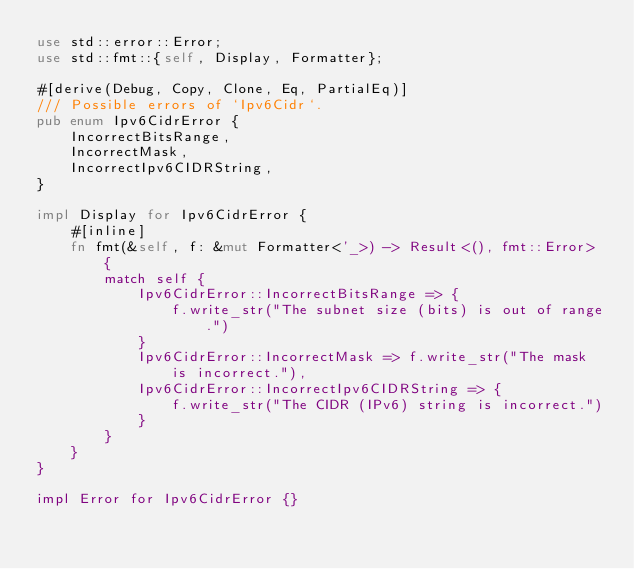<code> <loc_0><loc_0><loc_500><loc_500><_Rust_>use std::error::Error;
use std::fmt::{self, Display, Formatter};

#[derive(Debug, Copy, Clone, Eq, PartialEq)]
/// Possible errors of `Ipv6Cidr`.
pub enum Ipv6CidrError {
    IncorrectBitsRange,
    IncorrectMask,
    IncorrectIpv6CIDRString,
}

impl Display for Ipv6CidrError {
    #[inline]
    fn fmt(&self, f: &mut Formatter<'_>) -> Result<(), fmt::Error> {
        match self {
            Ipv6CidrError::IncorrectBitsRange => {
                f.write_str("The subnet size (bits) is out of range.")
            }
            Ipv6CidrError::IncorrectMask => f.write_str("The mask is incorrect."),
            Ipv6CidrError::IncorrectIpv6CIDRString => {
                f.write_str("The CIDR (IPv6) string is incorrect.")
            }
        }
    }
}

impl Error for Ipv6CidrError {}
</code> 